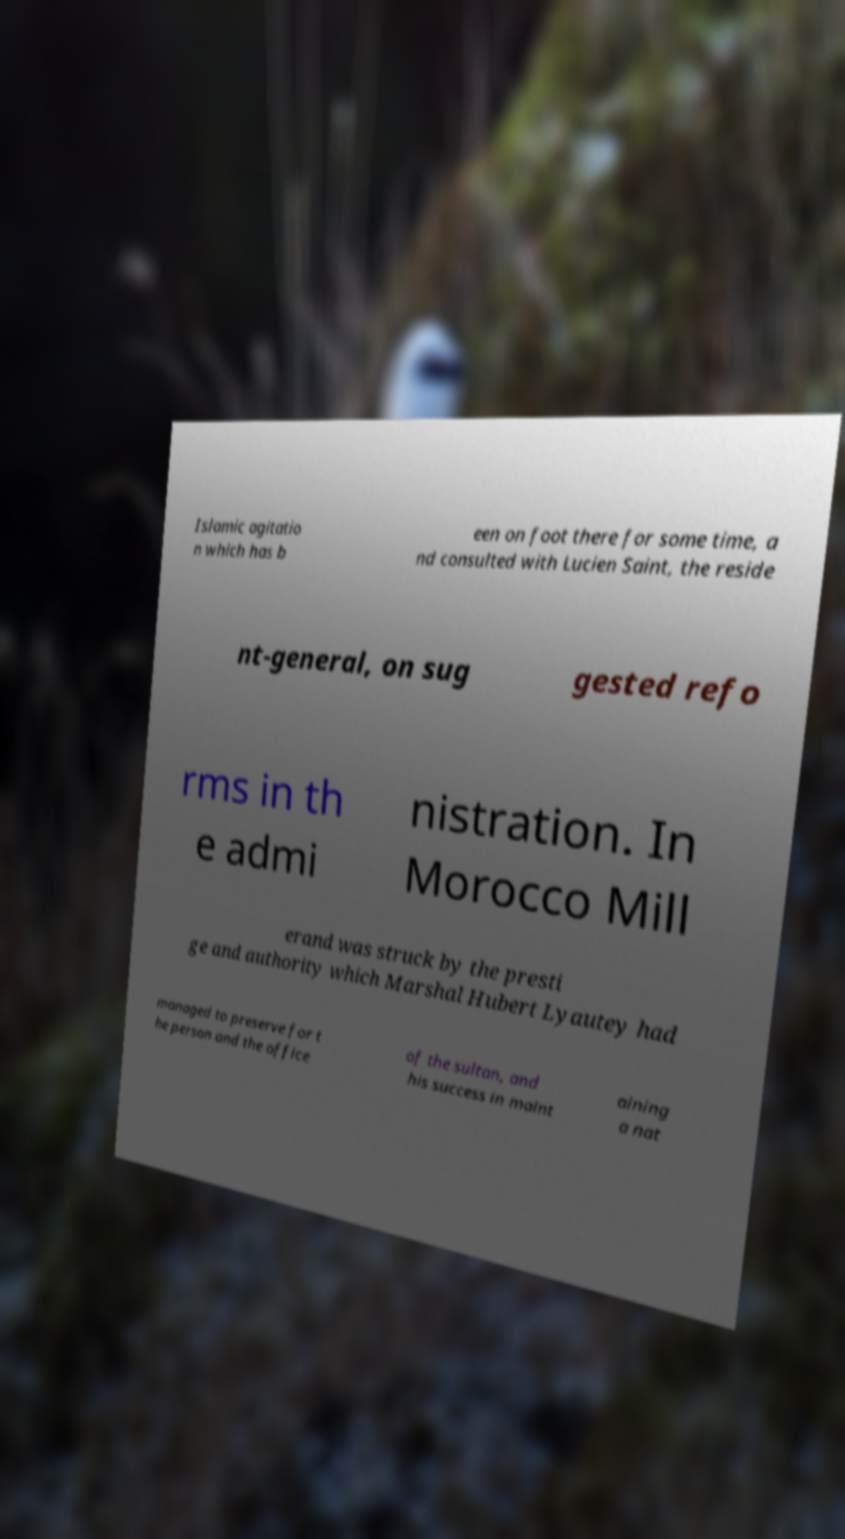I need the written content from this picture converted into text. Can you do that? Islamic agitatio n which has b een on foot there for some time, a nd consulted with Lucien Saint, the reside nt-general, on sug gested refo rms in th e admi nistration. In Morocco Mill erand was struck by the presti ge and authority which Marshal Hubert Lyautey had managed to preserve for t he person and the office of the sultan, and his success in maint aining a nat 